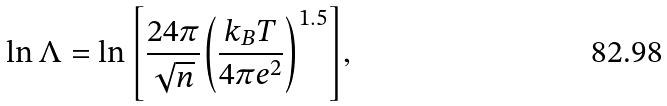Convert formula to latex. <formula><loc_0><loc_0><loc_500><loc_500>\ln { \Lambda } = \ln { \left [ \frac { 2 4 \pi } { \sqrt { n } } { \left ( \frac { k _ { B } T } { 4 \pi e ^ { 2 } } \right ) ^ { 1 . 5 } } \right ] } ,</formula> 